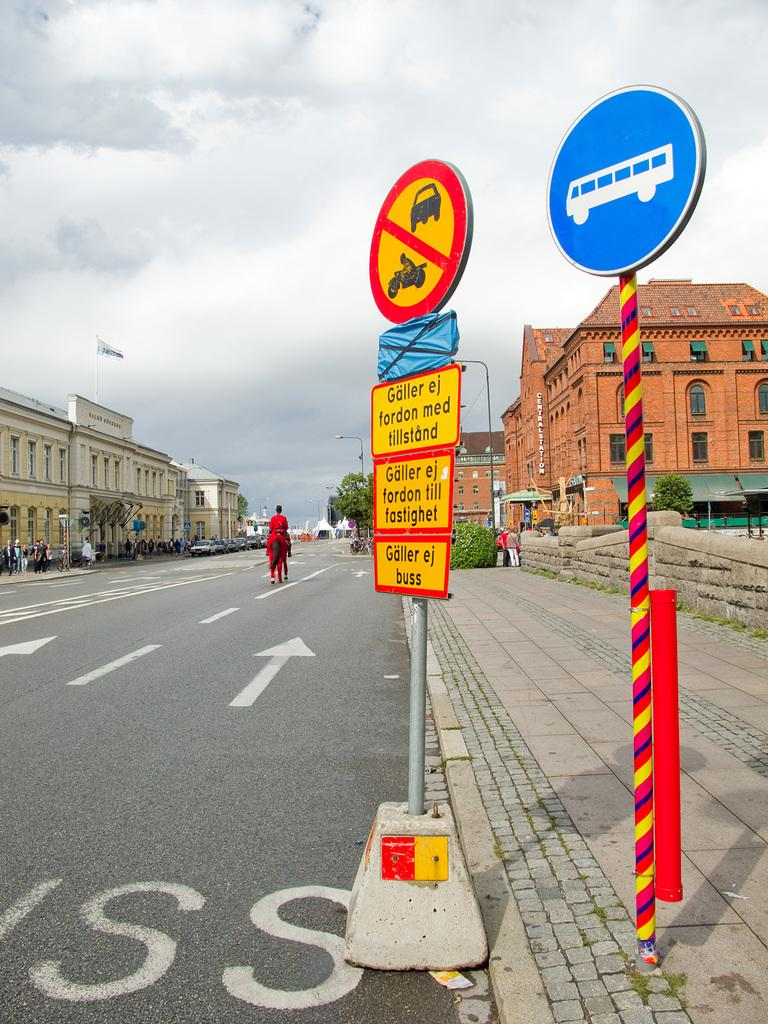Provide a one-sentence caption for the provided image. A sign at the bottom of a group of signs reads "Galler ej buss". 